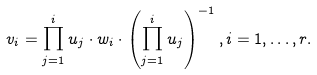<formula> <loc_0><loc_0><loc_500><loc_500>v _ { i } = \prod _ { j = 1 } ^ { i } u _ { j } \cdot w _ { i } \cdot \left ( \prod _ { j = 1 } ^ { i } u _ { j } \right ) ^ { - 1 } , i = 1 , \dots , r .</formula> 